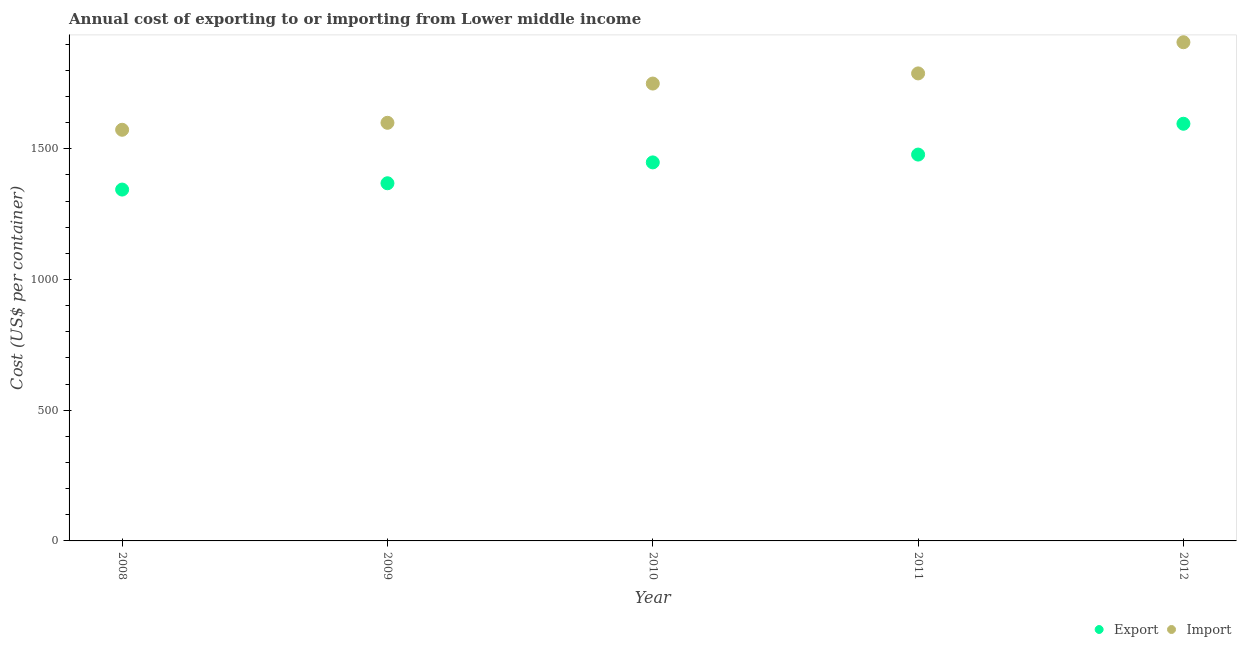How many different coloured dotlines are there?
Give a very brief answer. 2. What is the import cost in 2010?
Offer a very short reply. 1749.42. Across all years, what is the maximum export cost?
Your response must be concise. 1595.69. Across all years, what is the minimum export cost?
Your answer should be compact. 1343.96. In which year was the import cost maximum?
Keep it short and to the point. 2012. What is the total export cost in the graph?
Your response must be concise. 7233.37. What is the difference between the import cost in 2008 and that in 2009?
Provide a succinct answer. -26.67. What is the difference between the export cost in 2010 and the import cost in 2012?
Ensure brevity in your answer.  -459.61. What is the average export cost per year?
Provide a short and direct response. 1446.67. In the year 2009, what is the difference between the import cost and export cost?
Provide a succinct answer. 231.24. What is the ratio of the import cost in 2010 to that in 2012?
Provide a succinct answer. 0.92. Is the difference between the import cost in 2010 and 2012 greater than the difference between the export cost in 2010 and 2012?
Make the answer very short. No. What is the difference between the highest and the second highest export cost?
Your answer should be compact. 117.91. What is the difference between the highest and the lowest export cost?
Provide a short and direct response. 251.73. Is the sum of the export cost in 2008 and 2010 greater than the maximum import cost across all years?
Offer a very short reply. Yes. Does the import cost monotonically increase over the years?
Offer a terse response. Yes. Is the export cost strictly greater than the import cost over the years?
Make the answer very short. No. Is the import cost strictly less than the export cost over the years?
Provide a succinct answer. No. How many dotlines are there?
Give a very brief answer. 2. How many years are there in the graph?
Provide a short and direct response. 5. What is the difference between two consecutive major ticks on the Y-axis?
Your response must be concise. 500. Are the values on the major ticks of Y-axis written in scientific E-notation?
Offer a very short reply. No. Does the graph contain any zero values?
Make the answer very short. No. How many legend labels are there?
Your answer should be very brief. 2. What is the title of the graph?
Ensure brevity in your answer.  Annual cost of exporting to or importing from Lower middle income. What is the label or title of the Y-axis?
Keep it short and to the point. Cost (US$ per container). What is the Cost (US$ per container) in Export in 2008?
Keep it short and to the point. 1343.96. What is the Cost (US$ per container) in Import in 2008?
Offer a very short reply. 1572.65. What is the Cost (US$ per container) of Export in 2009?
Keep it short and to the point. 1368.08. What is the Cost (US$ per container) of Import in 2009?
Provide a short and direct response. 1599.32. What is the Cost (US$ per container) of Export in 2010?
Provide a succinct answer. 1447.86. What is the Cost (US$ per container) in Import in 2010?
Your response must be concise. 1749.42. What is the Cost (US$ per container) of Export in 2011?
Keep it short and to the point. 1477.78. What is the Cost (US$ per container) of Import in 2011?
Provide a short and direct response. 1788.26. What is the Cost (US$ per container) in Export in 2012?
Give a very brief answer. 1595.69. What is the Cost (US$ per container) of Import in 2012?
Your answer should be very brief. 1907.47. Across all years, what is the maximum Cost (US$ per container) of Export?
Your response must be concise. 1595.69. Across all years, what is the maximum Cost (US$ per container) in Import?
Give a very brief answer. 1907.47. Across all years, what is the minimum Cost (US$ per container) in Export?
Your answer should be compact. 1343.96. Across all years, what is the minimum Cost (US$ per container) in Import?
Give a very brief answer. 1572.65. What is the total Cost (US$ per container) in Export in the graph?
Offer a very short reply. 7233.37. What is the total Cost (US$ per container) of Import in the graph?
Ensure brevity in your answer.  8617.12. What is the difference between the Cost (US$ per container) in Export in 2008 and that in 2009?
Your response must be concise. -24.12. What is the difference between the Cost (US$ per container) of Import in 2008 and that in 2009?
Provide a short and direct response. -26.67. What is the difference between the Cost (US$ per container) in Export in 2008 and that in 2010?
Offer a very short reply. -103.9. What is the difference between the Cost (US$ per container) in Import in 2008 and that in 2010?
Ensure brevity in your answer.  -176.77. What is the difference between the Cost (US$ per container) in Export in 2008 and that in 2011?
Keep it short and to the point. -133.82. What is the difference between the Cost (US$ per container) of Import in 2008 and that in 2011?
Make the answer very short. -215.61. What is the difference between the Cost (US$ per container) of Export in 2008 and that in 2012?
Ensure brevity in your answer.  -251.73. What is the difference between the Cost (US$ per container) of Import in 2008 and that in 2012?
Your answer should be very brief. -334.82. What is the difference between the Cost (US$ per container) in Export in 2009 and that in 2010?
Ensure brevity in your answer.  -79.78. What is the difference between the Cost (US$ per container) in Import in 2009 and that in 2010?
Make the answer very short. -150.1. What is the difference between the Cost (US$ per container) in Export in 2009 and that in 2011?
Offer a very short reply. -109.7. What is the difference between the Cost (US$ per container) in Import in 2009 and that in 2011?
Your answer should be compact. -188.94. What is the difference between the Cost (US$ per container) of Export in 2009 and that in 2012?
Provide a short and direct response. -227.61. What is the difference between the Cost (US$ per container) of Import in 2009 and that in 2012?
Offer a terse response. -308.15. What is the difference between the Cost (US$ per container) of Export in 2010 and that in 2011?
Offer a very short reply. -29.92. What is the difference between the Cost (US$ per container) of Import in 2010 and that in 2011?
Make the answer very short. -38.84. What is the difference between the Cost (US$ per container) in Export in 2010 and that in 2012?
Offer a very short reply. -147.83. What is the difference between the Cost (US$ per container) in Import in 2010 and that in 2012?
Your answer should be compact. -158.05. What is the difference between the Cost (US$ per container) in Export in 2011 and that in 2012?
Provide a short and direct response. -117.91. What is the difference between the Cost (US$ per container) of Import in 2011 and that in 2012?
Keep it short and to the point. -119.21. What is the difference between the Cost (US$ per container) in Export in 2008 and the Cost (US$ per container) in Import in 2009?
Ensure brevity in your answer.  -255.36. What is the difference between the Cost (US$ per container) in Export in 2008 and the Cost (US$ per container) in Import in 2010?
Make the answer very short. -405.46. What is the difference between the Cost (US$ per container) of Export in 2008 and the Cost (US$ per container) of Import in 2011?
Ensure brevity in your answer.  -444.3. What is the difference between the Cost (US$ per container) of Export in 2008 and the Cost (US$ per container) of Import in 2012?
Your answer should be compact. -563.51. What is the difference between the Cost (US$ per container) of Export in 2009 and the Cost (US$ per container) of Import in 2010?
Make the answer very short. -381.34. What is the difference between the Cost (US$ per container) of Export in 2009 and the Cost (US$ per container) of Import in 2011?
Your response must be concise. -420.18. What is the difference between the Cost (US$ per container) in Export in 2009 and the Cost (US$ per container) in Import in 2012?
Offer a terse response. -539.39. What is the difference between the Cost (US$ per container) in Export in 2010 and the Cost (US$ per container) in Import in 2011?
Ensure brevity in your answer.  -340.4. What is the difference between the Cost (US$ per container) in Export in 2010 and the Cost (US$ per container) in Import in 2012?
Your response must be concise. -459.61. What is the difference between the Cost (US$ per container) of Export in 2011 and the Cost (US$ per container) of Import in 2012?
Offer a terse response. -429.69. What is the average Cost (US$ per container) in Export per year?
Provide a succinct answer. 1446.67. What is the average Cost (US$ per container) of Import per year?
Provide a short and direct response. 1723.42. In the year 2008, what is the difference between the Cost (US$ per container) of Export and Cost (US$ per container) of Import?
Ensure brevity in your answer.  -228.69. In the year 2009, what is the difference between the Cost (US$ per container) in Export and Cost (US$ per container) in Import?
Keep it short and to the point. -231.24. In the year 2010, what is the difference between the Cost (US$ per container) in Export and Cost (US$ per container) in Import?
Your answer should be very brief. -301.56. In the year 2011, what is the difference between the Cost (US$ per container) in Export and Cost (US$ per container) in Import?
Make the answer very short. -310.48. In the year 2012, what is the difference between the Cost (US$ per container) of Export and Cost (US$ per container) of Import?
Offer a terse response. -311.78. What is the ratio of the Cost (US$ per container) of Export in 2008 to that in 2009?
Keep it short and to the point. 0.98. What is the ratio of the Cost (US$ per container) in Import in 2008 to that in 2009?
Your answer should be compact. 0.98. What is the ratio of the Cost (US$ per container) of Export in 2008 to that in 2010?
Your answer should be compact. 0.93. What is the ratio of the Cost (US$ per container) in Import in 2008 to that in 2010?
Offer a very short reply. 0.9. What is the ratio of the Cost (US$ per container) in Export in 2008 to that in 2011?
Make the answer very short. 0.91. What is the ratio of the Cost (US$ per container) in Import in 2008 to that in 2011?
Provide a short and direct response. 0.88. What is the ratio of the Cost (US$ per container) of Export in 2008 to that in 2012?
Make the answer very short. 0.84. What is the ratio of the Cost (US$ per container) of Import in 2008 to that in 2012?
Offer a very short reply. 0.82. What is the ratio of the Cost (US$ per container) of Export in 2009 to that in 2010?
Your response must be concise. 0.94. What is the ratio of the Cost (US$ per container) in Import in 2009 to that in 2010?
Provide a short and direct response. 0.91. What is the ratio of the Cost (US$ per container) of Export in 2009 to that in 2011?
Your answer should be very brief. 0.93. What is the ratio of the Cost (US$ per container) of Import in 2009 to that in 2011?
Your response must be concise. 0.89. What is the ratio of the Cost (US$ per container) in Export in 2009 to that in 2012?
Your response must be concise. 0.86. What is the ratio of the Cost (US$ per container) in Import in 2009 to that in 2012?
Give a very brief answer. 0.84. What is the ratio of the Cost (US$ per container) in Export in 2010 to that in 2011?
Ensure brevity in your answer.  0.98. What is the ratio of the Cost (US$ per container) of Import in 2010 to that in 2011?
Offer a terse response. 0.98. What is the ratio of the Cost (US$ per container) in Export in 2010 to that in 2012?
Your answer should be compact. 0.91. What is the ratio of the Cost (US$ per container) of Import in 2010 to that in 2012?
Provide a succinct answer. 0.92. What is the ratio of the Cost (US$ per container) of Export in 2011 to that in 2012?
Your answer should be very brief. 0.93. What is the difference between the highest and the second highest Cost (US$ per container) in Export?
Offer a very short reply. 117.91. What is the difference between the highest and the second highest Cost (US$ per container) in Import?
Your answer should be very brief. 119.21. What is the difference between the highest and the lowest Cost (US$ per container) in Export?
Provide a short and direct response. 251.73. What is the difference between the highest and the lowest Cost (US$ per container) of Import?
Offer a terse response. 334.82. 